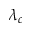Convert formula to latex. <formula><loc_0><loc_0><loc_500><loc_500>\lambda _ { c }</formula> 